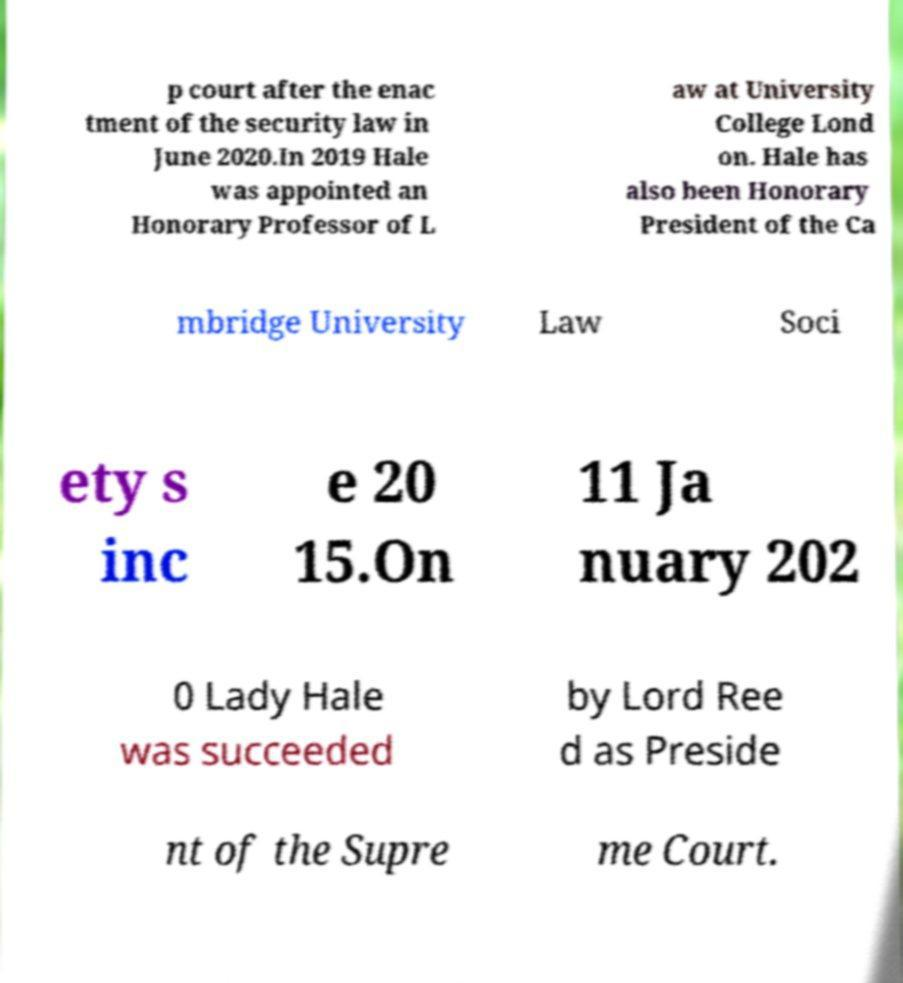Could you extract and type out the text from this image? p court after the enac tment of the security law in June 2020.In 2019 Hale was appointed an Honorary Professor of L aw at University College Lond on. Hale has also been Honorary President of the Ca mbridge University Law Soci ety s inc e 20 15.On 11 Ja nuary 202 0 Lady Hale was succeeded by Lord Ree d as Preside nt of the Supre me Court. 